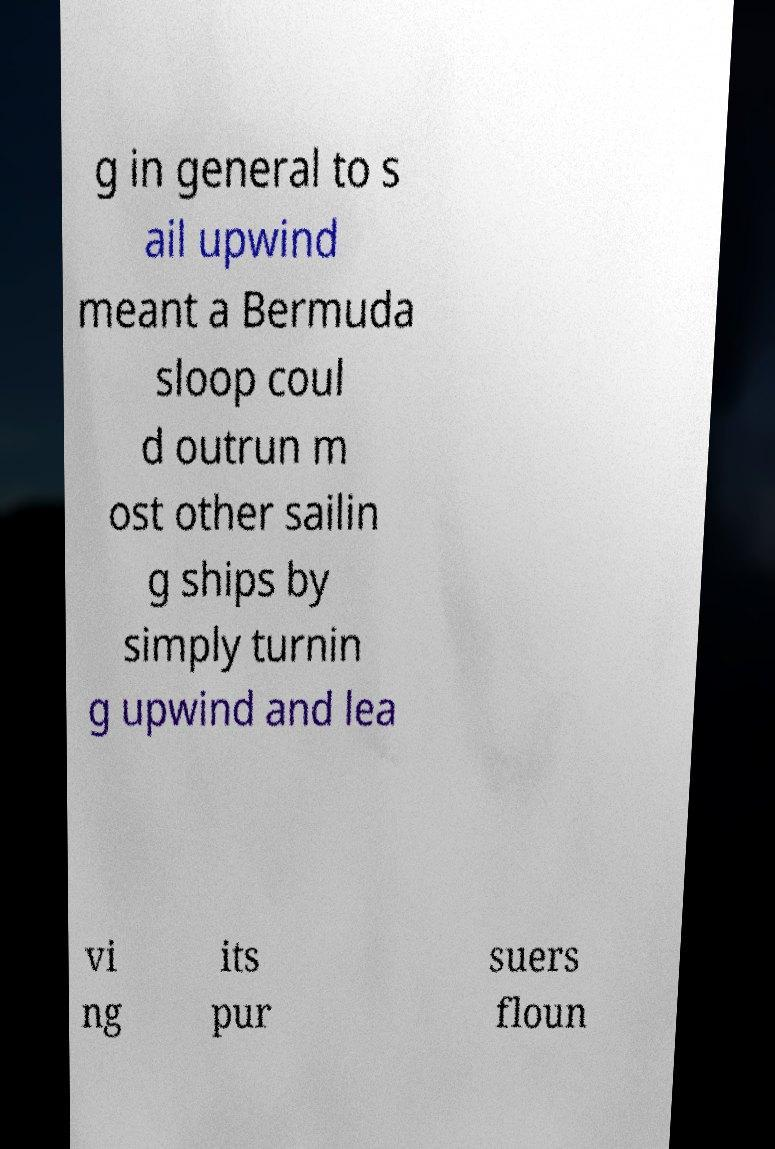Could you extract and type out the text from this image? g in general to s ail upwind meant a Bermuda sloop coul d outrun m ost other sailin g ships by simply turnin g upwind and lea vi ng its pur suers floun 